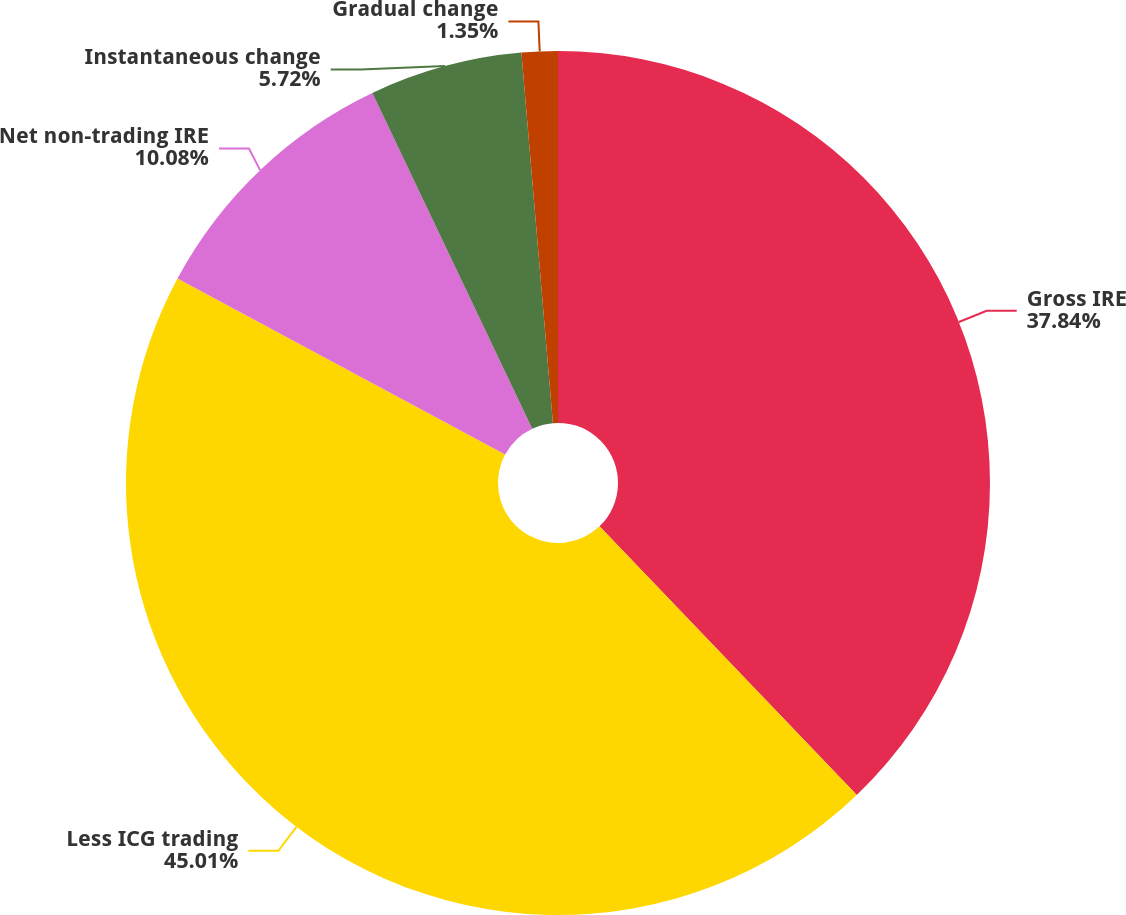Convert chart to OTSL. <chart><loc_0><loc_0><loc_500><loc_500><pie_chart><fcel>Gross IRE<fcel>Less ICG trading<fcel>Net non-trading IRE<fcel>Instantaneous change<fcel>Gradual change<nl><fcel>37.84%<fcel>45.0%<fcel>10.08%<fcel>5.72%<fcel>1.35%<nl></chart> 